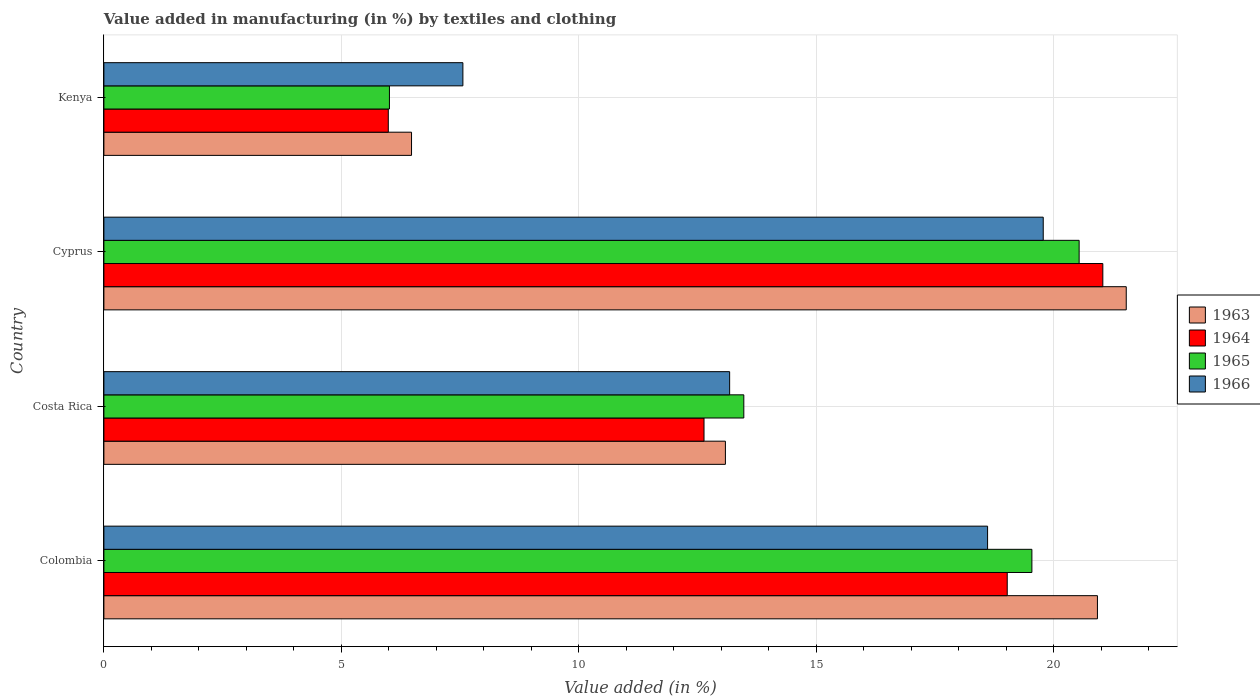How many different coloured bars are there?
Provide a succinct answer. 4. Are the number of bars per tick equal to the number of legend labels?
Make the answer very short. Yes. In how many cases, is the number of bars for a given country not equal to the number of legend labels?
Offer a terse response. 0. What is the percentage of value added in manufacturing by textiles and clothing in 1964 in Kenya?
Give a very brief answer. 5.99. Across all countries, what is the maximum percentage of value added in manufacturing by textiles and clothing in 1966?
Make the answer very short. 19.78. Across all countries, what is the minimum percentage of value added in manufacturing by textiles and clothing in 1966?
Keep it short and to the point. 7.56. In which country was the percentage of value added in manufacturing by textiles and clothing in 1966 maximum?
Make the answer very short. Cyprus. In which country was the percentage of value added in manufacturing by textiles and clothing in 1965 minimum?
Give a very brief answer. Kenya. What is the total percentage of value added in manufacturing by textiles and clothing in 1964 in the graph?
Give a very brief answer. 58.67. What is the difference between the percentage of value added in manufacturing by textiles and clothing in 1966 in Colombia and that in Costa Rica?
Your answer should be compact. 5.43. What is the difference between the percentage of value added in manufacturing by textiles and clothing in 1965 in Kenya and the percentage of value added in manufacturing by textiles and clothing in 1964 in Costa Rica?
Offer a terse response. -6.62. What is the average percentage of value added in manufacturing by textiles and clothing in 1963 per country?
Keep it short and to the point. 15.5. What is the difference between the percentage of value added in manufacturing by textiles and clothing in 1964 and percentage of value added in manufacturing by textiles and clothing in 1966 in Cyprus?
Provide a succinct answer. 1.25. In how many countries, is the percentage of value added in manufacturing by textiles and clothing in 1966 greater than 21 %?
Give a very brief answer. 0. What is the ratio of the percentage of value added in manufacturing by textiles and clothing in 1964 in Costa Rica to that in Cyprus?
Your answer should be compact. 0.6. Is the percentage of value added in manufacturing by textiles and clothing in 1964 in Colombia less than that in Kenya?
Offer a very short reply. No. Is the difference between the percentage of value added in manufacturing by textiles and clothing in 1964 in Costa Rica and Cyprus greater than the difference between the percentage of value added in manufacturing by textiles and clothing in 1966 in Costa Rica and Cyprus?
Offer a very short reply. No. What is the difference between the highest and the second highest percentage of value added in manufacturing by textiles and clothing in 1964?
Provide a short and direct response. 2.01. What is the difference between the highest and the lowest percentage of value added in manufacturing by textiles and clothing in 1963?
Provide a succinct answer. 15.05. In how many countries, is the percentage of value added in manufacturing by textiles and clothing in 1964 greater than the average percentage of value added in manufacturing by textiles and clothing in 1964 taken over all countries?
Your response must be concise. 2. What does the 3rd bar from the bottom in Cyprus represents?
Your response must be concise. 1965. Is it the case that in every country, the sum of the percentage of value added in manufacturing by textiles and clothing in 1964 and percentage of value added in manufacturing by textiles and clothing in 1965 is greater than the percentage of value added in manufacturing by textiles and clothing in 1963?
Keep it short and to the point. Yes. How many countries are there in the graph?
Make the answer very short. 4. What is the difference between two consecutive major ticks on the X-axis?
Keep it short and to the point. 5. Does the graph contain any zero values?
Your answer should be compact. No. Does the graph contain grids?
Give a very brief answer. Yes. How many legend labels are there?
Ensure brevity in your answer.  4. What is the title of the graph?
Your answer should be compact. Value added in manufacturing (in %) by textiles and clothing. Does "2011" appear as one of the legend labels in the graph?
Provide a short and direct response. No. What is the label or title of the X-axis?
Provide a short and direct response. Value added (in %). What is the label or title of the Y-axis?
Your response must be concise. Country. What is the Value added (in %) of 1963 in Colombia?
Provide a succinct answer. 20.92. What is the Value added (in %) of 1964 in Colombia?
Provide a succinct answer. 19.02. What is the Value added (in %) in 1965 in Colombia?
Ensure brevity in your answer.  19.54. What is the Value added (in %) of 1966 in Colombia?
Provide a short and direct response. 18.6. What is the Value added (in %) of 1963 in Costa Rica?
Provide a short and direct response. 13.08. What is the Value added (in %) in 1964 in Costa Rica?
Provide a short and direct response. 12.63. What is the Value added (in %) in 1965 in Costa Rica?
Your answer should be very brief. 13.47. What is the Value added (in %) of 1966 in Costa Rica?
Your answer should be compact. 13.17. What is the Value added (in %) in 1963 in Cyprus?
Provide a succinct answer. 21.52. What is the Value added (in %) in 1964 in Cyprus?
Ensure brevity in your answer.  21.03. What is the Value added (in %) of 1965 in Cyprus?
Ensure brevity in your answer.  20.53. What is the Value added (in %) of 1966 in Cyprus?
Give a very brief answer. 19.78. What is the Value added (in %) of 1963 in Kenya?
Provide a succinct answer. 6.48. What is the Value added (in %) in 1964 in Kenya?
Offer a terse response. 5.99. What is the Value added (in %) in 1965 in Kenya?
Offer a very short reply. 6.01. What is the Value added (in %) of 1966 in Kenya?
Offer a terse response. 7.56. Across all countries, what is the maximum Value added (in %) of 1963?
Offer a very short reply. 21.52. Across all countries, what is the maximum Value added (in %) of 1964?
Ensure brevity in your answer.  21.03. Across all countries, what is the maximum Value added (in %) in 1965?
Keep it short and to the point. 20.53. Across all countries, what is the maximum Value added (in %) of 1966?
Your answer should be compact. 19.78. Across all countries, what is the minimum Value added (in %) in 1963?
Provide a succinct answer. 6.48. Across all countries, what is the minimum Value added (in %) of 1964?
Your response must be concise. 5.99. Across all countries, what is the minimum Value added (in %) in 1965?
Provide a short and direct response. 6.01. Across all countries, what is the minimum Value added (in %) of 1966?
Provide a short and direct response. 7.56. What is the total Value added (in %) in 1963 in the graph?
Your answer should be very brief. 62. What is the total Value added (in %) of 1964 in the graph?
Provide a succinct answer. 58.67. What is the total Value added (in %) of 1965 in the graph?
Give a very brief answer. 59.55. What is the total Value added (in %) in 1966 in the graph?
Ensure brevity in your answer.  59.11. What is the difference between the Value added (in %) in 1963 in Colombia and that in Costa Rica?
Your answer should be compact. 7.83. What is the difference between the Value added (in %) of 1964 in Colombia and that in Costa Rica?
Make the answer very short. 6.38. What is the difference between the Value added (in %) of 1965 in Colombia and that in Costa Rica?
Make the answer very short. 6.06. What is the difference between the Value added (in %) of 1966 in Colombia and that in Costa Rica?
Keep it short and to the point. 5.43. What is the difference between the Value added (in %) in 1963 in Colombia and that in Cyprus?
Your answer should be very brief. -0.61. What is the difference between the Value added (in %) of 1964 in Colombia and that in Cyprus?
Your response must be concise. -2.01. What is the difference between the Value added (in %) in 1965 in Colombia and that in Cyprus?
Offer a very short reply. -0.99. What is the difference between the Value added (in %) of 1966 in Colombia and that in Cyprus?
Your response must be concise. -1.17. What is the difference between the Value added (in %) in 1963 in Colombia and that in Kenya?
Make the answer very short. 14.44. What is the difference between the Value added (in %) of 1964 in Colombia and that in Kenya?
Give a very brief answer. 13.03. What is the difference between the Value added (in %) in 1965 in Colombia and that in Kenya?
Your answer should be compact. 13.53. What is the difference between the Value added (in %) in 1966 in Colombia and that in Kenya?
Provide a short and direct response. 11.05. What is the difference between the Value added (in %) of 1963 in Costa Rica and that in Cyprus?
Your response must be concise. -8.44. What is the difference between the Value added (in %) in 1964 in Costa Rica and that in Cyprus?
Give a very brief answer. -8.4. What is the difference between the Value added (in %) in 1965 in Costa Rica and that in Cyprus?
Your response must be concise. -7.06. What is the difference between the Value added (in %) in 1966 in Costa Rica and that in Cyprus?
Your answer should be very brief. -6.6. What is the difference between the Value added (in %) of 1963 in Costa Rica and that in Kenya?
Provide a short and direct response. 6.61. What is the difference between the Value added (in %) in 1964 in Costa Rica and that in Kenya?
Give a very brief answer. 6.65. What is the difference between the Value added (in %) in 1965 in Costa Rica and that in Kenya?
Your answer should be compact. 7.46. What is the difference between the Value added (in %) of 1966 in Costa Rica and that in Kenya?
Keep it short and to the point. 5.62. What is the difference between the Value added (in %) in 1963 in Cyprus and that in Kenya?
Provide a short and direct response. 15.05. What is the difference between the Value added (in %) of 1964 in Cyprus and that in Kenya?
Ensure brevity in your answer.  15.04. What is the difference between the Value added (in %) in 1965 in Cyprus and that in Kenya?
Give a very brief answer. 14.52. What is the difference between the Value added (in %) in 1966 in Cyprus and that in Kenya?
Ensure brevity in your answer.  12.22. What is the difference between the Value added (in %) of 1963 in Colombia and the Value added (in %) of 1964 in Costa Rica?
Make the answer very short. 8.28. What is the difference between the Value added (in %) in 1963 in Colombia and the Value added (in %) in 1965 in Costa Rica?
Provide a succinct answer. 7.44. What is the difference between the Value added (in %) in 1963 in Colombia and the Value added (in %) in 1966 in Costa Rica?
Provide a short and direct response. 7.74. What is the difference between the Value added (in %) in 1964 in Colombia and the Value added (in %) in 1965 in Costa Rica?
Make the answer very short. 5.55. What is the difference between the Value added (in %) in 1964 in Colombia and the Value added (in %) in 1966 in Costa Rica?
Your answer should be compact. 5.84. What is the difference between the Value added (in %) in 1965 in Colombia and the Value added (in %) in 1966 in Costa Rica?
Offer a very short reply. 6.36. What is the difference between the Value added (in %) of 1963 in Colombia and the Value added (in %) of 1964 in Cyprus?
Provide a short and direct response. -0.11. What is the difference between the Value added (in %) in 1963 in Colombia and the Value added (in %) in 1965 in Cyprus?
Ensure brevity in your answer.  0.39. What is the difference between the Value added (in %) of 1963 in Colombia and the Value added (in %) of 1966 in Cyprus?
Offer a terse response. 1.14. What is the difference between the Value added (in %) in 1964 in Colombia and the Value added (in %) in 1965 in Cyprus?
Provide a short and direct response. -1.51. What is the difference between the Value added (in %) in 1964 in Colombia and the Value added (in %) in 1966 in Cyprus?
Your answer should be compact. -0.76. What is the difference between the Value added (in %) in 1965 in Colombia and the Value added (in %) in 1966 in Cyprus?
Your answer should be compact. -0.24. What is the difference between the Value added (in %) of 1963 in Colombia and the Value added (in %) of 1964 in Kenya?
Your response must be concise. 14.93. What is the difference between the Value added (in %) of 1963 in Colombia and the Value added (in %) of 1965 in Kenya?
Ensure brevity in your answer.  14.91. What is the difference between the Value added (in %) in 1963 in Colombia and the Value added (in %) in 1966 in Kenya?
Offer a very short reply. 13.36. What is the difference between the Value added (in %) of 1964 in Colombia and the Value added (in %) of 1965 in Kenya?
Keep it short and to the point. 13.01. What is the difference between the Value added (in %) of 1964 in Colombia and the Value added (in %) of 1966 in Kenya?
Keep it short and to the point. 11.46. What is the difference between the Value added (in %) in 1965 in Colombia and the Value added (in %) in 1966 in Kenya?
Your response must be concise. 11.98. What is the difference between the Value added (in %) in 1963 in Costa Rica and the Value added (in %) in 1964 in Cyprus?
Your answer should be compact. -7.95. What is the difference between the Value added (in %) in 1963 in Costa Rica and the Value added (in %) in 1965 in Cyprus?
Your answer should be very brief. -7.45. What is the difference between the Value added (in %) of 1963 in Costa Rica and the Value added (in %) of 1966 in Cyprus?
Keep it short and to the point. -6.69. What is the difference between the Value added (in %) in 1964 in Costa Rica and the Value added (in %) in 1965 in Cyprus?
Give a very brief answer. -7.9. What is the difference between the Value added (in %) of 1964 in Costa Rica and the Value added (in %) of 1966 in Cyprus?
Provide a short and direct response. -7.14. What is the difference between the Value added (in %) in 1965 in Costa Rica and the Value added (in %) in 1966 in Cyprus?
Provide a short and direct response. -6.3. What is the difference between the Value added (in %) in 1963 in Costa Rica and the Value added (in %) in 1964 in Kenya?
Offer a terse response. 7.1. What is the difference between the Value added (in %) of 1963 in Costa Rica and the Value added (in %) of 1965 in Kenya?
Give a very brief answer. 7.07. What is the difference between the Value added (in %) in 1963 in Costa Rica and the Value added (in %) in 1966 in Kenya?
Your answer should be compact. 5.53. What is the difference between the Value added (in %) of 1964 in Costa Rica and the Value added (in %) of 1965 in Kenya?
Offer a very short reply. 6.62. What is the difference between the Value added (in %) in 1964 in Costa Rica and the Value added (in %) in 1966 in Kenya?
Provide a succinct answer. 5.08. What is the difference between the Value added (in %) in 1965 in Costa Rica and the Value added (in %) in 1966 in Kenya?
Provide a short and direct response. 5.91. What is the difference between the Value added (in %) in 1963 in Cyprus and the Value added (in %) in 1964 in Kenya?
Provide a succinct answer. 15.54. What is the difference between the Value added (in %) in 1963 in Cyprus and the Value added (in %) in 1965 in Kenya?
Give a very brief answer. 15.51. What is the difference between the Value added (in %) in 1963 in Cyprus and the Value added (in %) in 1966 in Kenya?
Provide a succinct answer. 13.97. What is the difference between the Value added (in %) in 1964 in Cyprus and the Value added (in %) in 1965 in Kenya?
Your answer should be very brief. 15.02. What is the difference between the Value added (in %) in 1964 in Cyprus and the Value added (in %) in 1966 in Kenya?
Your answer should be very brief. 13.47. What is the difference between the Value added (in %) of 1965 in Cyprus and the Value added (in %) of 1966 in Kenya?
Keep it short and to the point. 12.97. What is the average Value added (in %) of 1963 per country?
Provide a short and direct response. 15.5. What is the average Value added (in %) of 1964 per country?
Provide a short and direct response. 14.67. What is the average Value added (in %) of 1965 per country?
Ensure brevity in your answer.  14.89. What is the average Value added (in %) of 1966 per country?
Give a very brief answer. 14.78. What is the difference between the Value added (in %) of 1963 and Value added (in %) of 1964 in Colombia?
Offer a terse response. 1.9. What is the difference between the Value added (in %) in 1963 and Value added (in %) in 1965 in Colombia?
Your answer should be very brief. 1.38. What is the difference between the Value added (in %) in 1963 and Value added (in %) in 1966 in Colombia?
Your response must be concise. 2.31. What is the difference between the Value added (in %) of 1964 and Value added (in %) of 1965 in Colombia?
Ensure brevity in your answer.  -0.52. What is the difference between the Value added (in %) of 1964 and Value added (in %) of 1966 in Colombia?
Provide a succinct answer. 0.41. What is the difference between the Value added (in %) of 1965 and Value added (in %) of 1966 in Colombia?
Give a very brief answer. 0.93. What is the difference between the Value added (in %) of 1963 and Value added (in %) of 1964 in Costa Rica?
Make the answer very short. 0.45. What is the difference between the Value added (in %) in 1963 and Value added (in %) in 1965 in Costa Rica?
Give a very brief answer. -0.39. What is the difference between the Value added (in %) in 1963 and Value added (in %) in 1966 in Costa Rica?
Your answer should be very brief. -0.09. What is the difference between the Value added (in %) of 1964 and Value added (in %) of 1965 in Costa Rica?
Provide a short and direct response. -0.84. What is the difference between the Value added (in %) of 1964 and Value added (in %) of 1966 in Costa Rica?
Give a very brief answer. -0.54. What is the difference between the Value added (in %) of 1965 and Value added (in %) of 1966 in Costa Rica?
Give a very brief answer. 0.3. What is the difference between the Value added (in %) of 1963 and Value added (in %) of 1964 in Cyprus?
Provide a short and direct response. 0.49. What is the difference between the Value added (in %) of 1963 and Value added (in %) of 1966 in Cyprus?
Your response must be concise. 1.75. What is the difference between the Value added (in %) of 1964 and Value added (in %) of 1965 in Cyprus?
Make the answer very short. 0.5. What is the difference between the Value added (in %) of 1964 and Value added (in %) of 1966 in Cyprus?
Offer a terse response. 1.25. What is the difference between the Value added (in %) of 1965 and Value added (in %) of 1966 in Cyprus?
Keep it short and to the point. 0.76. What is the difference between the Value added (in %) in 1963 and Value added (in %) in 1964 in Kenya?
Make the answer very short. 0.49. What is the difference between the Value added (in %) in 1963 and Value added (in %) in 1965 in Kenya?
Ensure brevity in your answer.  0.47. What is the difference between the Value added (in %) of 1963 and Value added (in %) of 1966 in Kenya?
Ensure brevity in your answer.  -1.08. What is the difference between the Value added (in %) in 1964 and Value added (in %) in 1965 in Kenya?
Give a very brief answer. -0.02. What is the difference between the Value added (in %) in 1964 and Value added (in %) in 1966 in Kenya?
Offer a very short reply. -1.57. What is the difference between the Value added (in %) in 1965 and Value added (in %) in 1966 in Kenya?
Provide a short and direct response. -1.55. What is the ratio of the Value added (in %) of 1963 in Colombia to that in Costa Rica?
Keep it short and to the point. 1.6. What is the ratio of the Value added (in %) of 1964 in Colombia to that in Costa Rica?
Your response must be concise. 1.51. What is the ratio of the Value added (in %) in 1965 in Colombia to that in Costa Rica?
Offer a very short reply. 1.45. What is the ratio of the Value added (in %) of 1966 in Colombia to that in Costa Rica?
Your response must be concise. 1.41. What is the ratio of the Value added (in %) in 1963 in Colombia to that in Cyprus?
Ensure brevity in your answer.  0.97. What is the ratio of the Value added (in %) of 1964 in Colombia to that in Cyprus?
Your response must be concise. 0.9. What is the ratio of the Value added (in %) in 1965 in Colombia to that in Cyprus?
Offer a very short reply. 0.95. What is the ratio of the Value added (in %) in 1966 in Colombia to that in Cyprus?
Provide a short and direct response. 0.94. What is the ratio of the Value added (in %) in 1963 in Colombia to that in Kenya?
Your answer should be very brief. 3.23. What is the ratio of the Value added (in %) of 1964 in Colombia to that in Kenya?
Offer a terse response. 3.18. What is the ratio of the Value added (in %) of 1966 in Colombia to that in Kenya?
Your answer should be compact. 2.46. What is the ratio of the Value added (in %) of 1963 in Costa Rica to that in Cyprus?
Keep it short and to the point. 0.61. What is the ratio of the Value added (in %) of 1964 in Costa Rica to that in Cyprus?
Ensure brevity in your answer.  0.6. What is the ratio of the Value added (in %) in 1965 in Costa Rica to that in Cyprus?
Provide a succinct answer. 0.66. What is the ratio of the Value added (in %) of 1966 in Costa Rica to that in Cyprus?
Your answer should be very brief. 0.67. What is the ratio of the Value added (in %) in 1963 in Costa Rica to that in Kenya?
Give a very brief answer. 2.02. What is the ratio of the Value added (in %) in 1964 in Costa Rica to that in Kenya?
Give a very brief answer. 2.11. What is the ratio of the Value added (in %) in 1965 in Costa Rica to that in Kenya?
Give a very brief answer. 2.24. What is the ratio of the Value added (in %) in 1966 in Costa Rica to that in Kenya?
Offer a very short reply. 1.74. What is the ratio of the Value added (in %) in 1963 in Cyprus to that in Kenya?
Your answer should be very brief. 3.32. What is the ratio of the Value added (in %) of 1964 in Cyprus to that in Kenya?
Your answer should be very brief. 3.51. What is the ratio of the Value added (in %) in 1965 in Cyprus to that in Kenya?
Offer a very short reply. 3.42. What is the ratio of the Value added (in %) in 1966 in Cyprus to that in Kenya?
Offer a terse response. 2.62. What is the difference between the highest and the second highest Value added (in %) in 1963?
Offer a very short reply. 0.61. What is the difference between the highest and the second highest Value added (in %) of 1964?
Provide a succinct answer. 2.01. What is the difference between the highest and the second highest Value added (in %) of 1966?
Ensure brevity in your answer.  1.17. What is the difference between the highest and the lowest Value added (in %) of 1963?
Give a very brief answer. 15.05. What is the difference between the highest and the lowest Value added (in %) in 1964?
Make the answer very short. 15.04. What is the difference between the highest and the lowest Value added (in %) of 1965?
Your answer should be compact. 14.52. What is the difference between the highest and the lowest Value added (in %) in 1966?
Give a very brief answer. 12.22. 